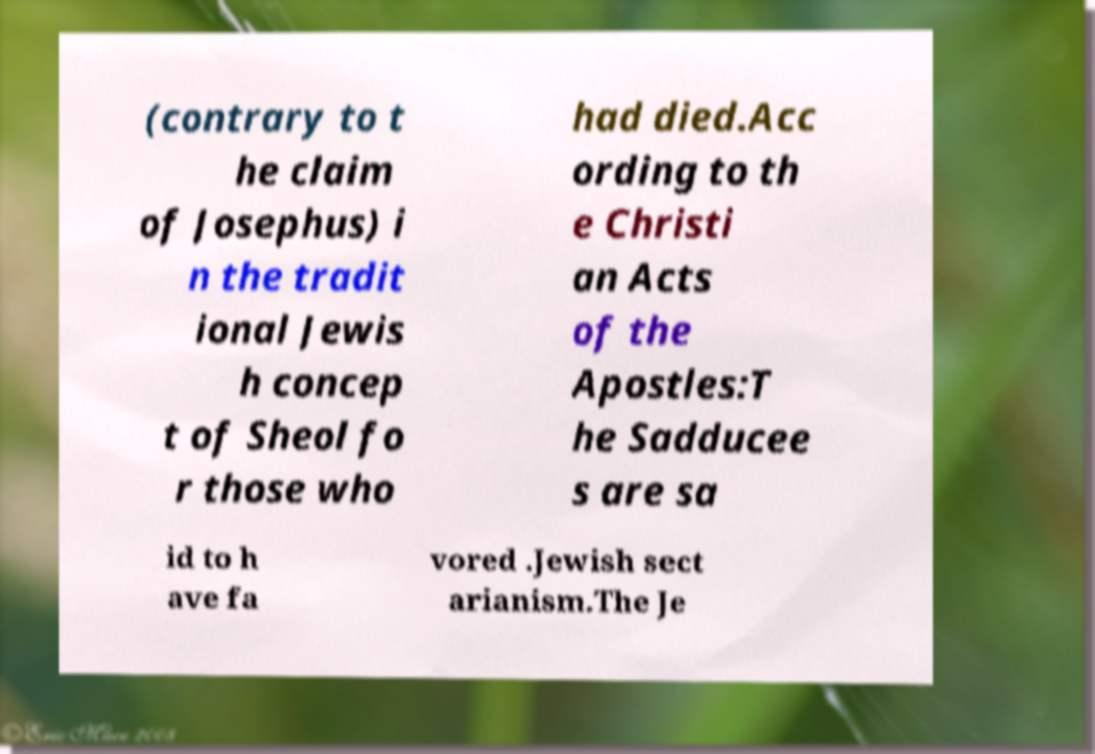Can you accurately transcribe the text from the provided image for me? (contrary to t he claim of Josephus) i n the tradit ional Jewis h concep t of Sheol fo r those who had died.Acc ording to th e Christi an Acts of the Apostles:T he Sadducee s are sa id to h ave fa vored .Jewish sect arianism.The Je 